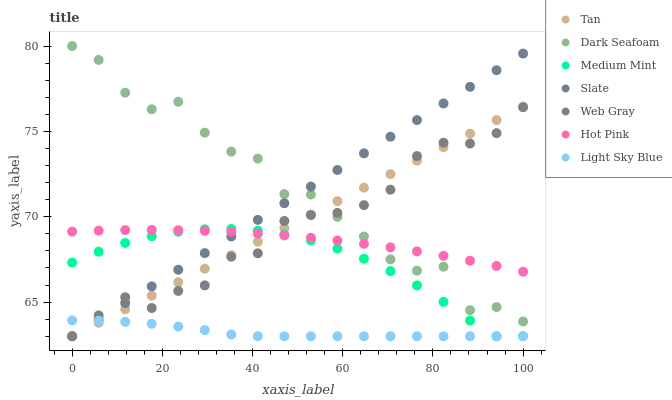Does Light Sky Blue have the minimum area under the curve?
Answer yes or no. Yes. Does Dark Seafoam have the maximum area under the curve?
Answer yes or no. Yes. Does Web Gray have the minimum area under the curve?
Answer yes or no. No. Does Web Gray have the maximum area under the curve?
Answer yes or no. No. Is Slate the smoothest?
Answer yes or no. Yes. Is Dark Seafoam the roughest?
Answer yes or no. Yes. Is Web Gray the smoothest?
Answer yes or no. No. Is Web Gray the roughest?
Answer yes or no. No. Does Medium Mint have the lowest value?
Answer yes or no. Yes. Does Hot Pink have the lowest value?
Answer yes or no. No. Does Dark Seafoam have the highest value?
Answer yes or no. Yes. Does Web Gray have the highest value?
Answer yes or no. No. Is Light Sky Blue less than Hot Pink?
Answer yes or no. Yes. Is Dark Seafoam greater than Light Sky Blue?
Answer yes or no. Yes. Does Web Gray intersect Dark Seafoam?
Answer yes or no. Yes. Is Web Gray less than Dark Seafoam?
Answer yes or no. No. Is Web Gray greater than Dark Seafoam?
Answer yes or no. No. Does Light Sky Blue intersect Hot Pink?
Answer yes or no. No. 